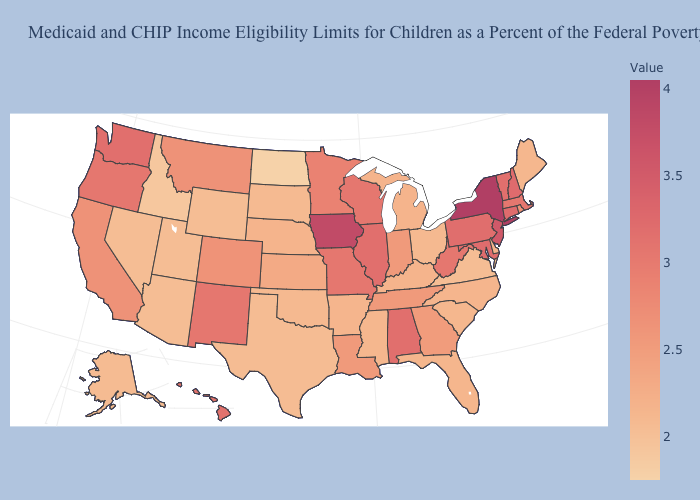Is the legend a continuous bar?
Keep it brief. Yes. Does New York have the highest value in the USA?
Give a very brief answer. Yes. Does Wisconsin have a higher value than New York?
Concise answer only. No. Does the map have missing data?
Write a very short answer. No. Which states have the lowest value in the South?
Be succinct. Virginia. Does Maine have a higher value than Montana?
Short answer required. No. Does Missouri have the highest value in the MidWest?
Answer briefly. No. Which states have the highest value in the USA?
Short answer required. New York. 